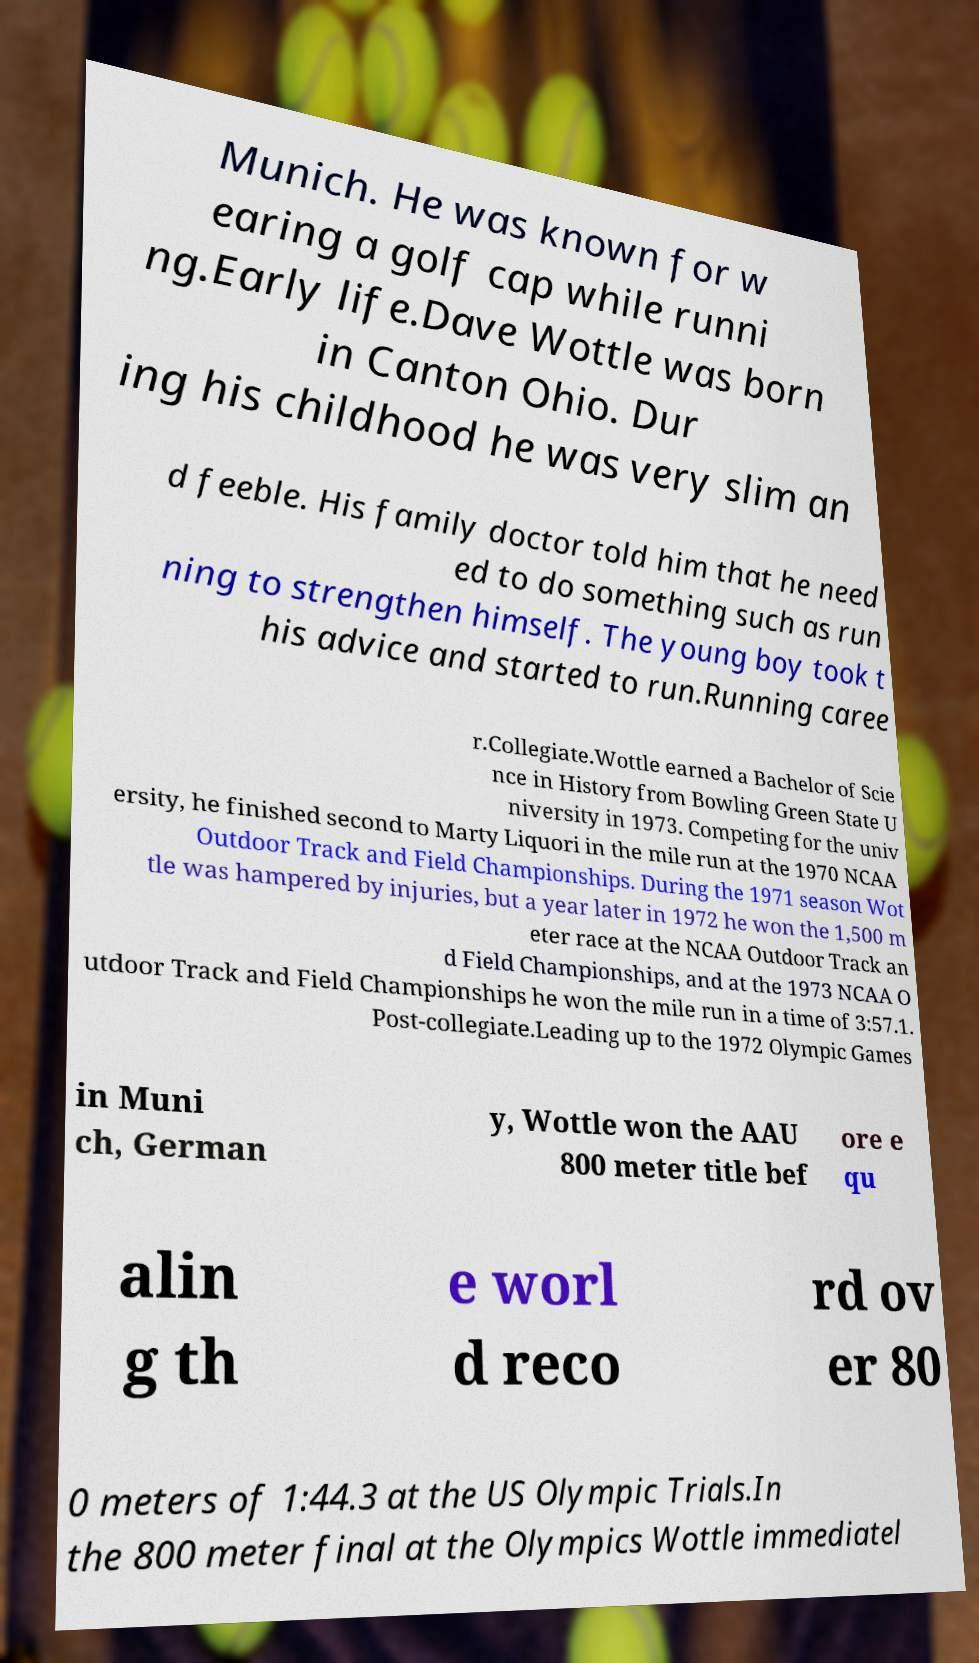Can you accurately transcribe the text from the provided image for me? Munich. He was known for w earing a golf cap while runni ng.Early life.Dave Wottle was born in Canton Ohio. Dur ing his childhood he was very slim an d feeble. His family doctor told him that he need ed to do something such as run ning to strengthen himself. The young boy took t his advice and started to run.Running caree r.Collegiate.Wottle earned a Bachelor of Scie nce in History from Bowling Green State U niversity in 1973. Competing for the univ ersity, he finished second to Marty Liquori in the mile run at the 1970 NCAA Outdoor Track and Field Championships. During the 1971 season Wot tle was hampered by injuries, but a year later in 1972 he won the 1,500 m eter race at the NCAA Outdoor Track an d Field Championships, and at the 1973 NCAA O utdoor Track and Field Championships he won the mile run in a time of 3:57.1. Post-collegiate.Leading up to the 1972 Olympic Games in Muni ch, German y, Wottle won the AAU 800 meter title bef ore e qu alin g th e worl d reco rd ov er 80 0 meters of 1:44.3 at the US Olympic Trials.In the 800 meter final at the Olympics Wottle immediatel 